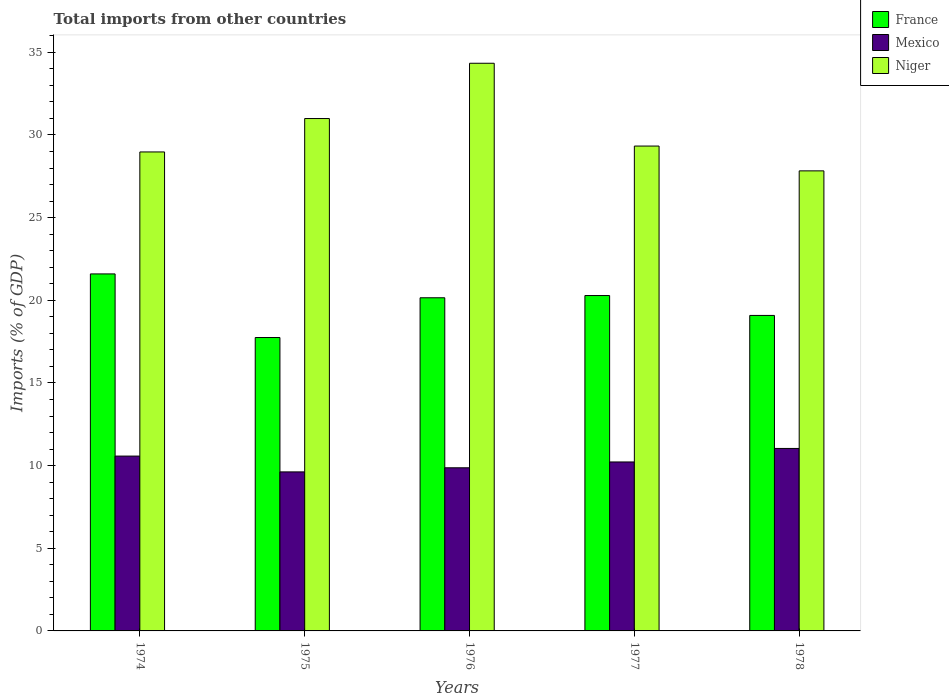How many different coloured bars are there?
Keep it short and to the point. 3. Are the number of bars per tick equal to the number of legend labels?
Your answer should be very brief. Yes. Are the number of bars on each tick of the X-axis equal?
Your answer should be very brief. Yes. How many bars are there on the 5th tick from the left?
Offer a terse response. 3. What is the label of the 5th group of bars from the left?
Your answer should be very brief. 1978. In how many cases, is the number of bars for a given year not equal to the number of legend labels?
Your answer should be compact. 0. What is the total imports in France in 1977?
Offer a very short reply. 20.29. Across all years, what is the maximum total imports in France?
Your response must be concise. 21.6. Across all years, what is the minimum total imports in Mexico?
Offer a terse response. 9.62. In which year was the total imports in Niger maximum?
Your answer should be very brief. 1976. In which year was the total imports in France minimum?
Make the answer very short. 1975. What is the total total imports in Mexico in the graph?
Give a very brief answer. 51.32. What is the difference between the total imports in Mexico in 1975 and that in 1978?
Your answer should be very brief. -1.42. What is the difference between the total imports in Mexico in 1977 and the total imports in France in 1978?
Offer a terse response. -8.86. What is the average total imports in Niger per year?
Ensure brevity in your answer.  30.29. In the year 1974, what is the difference between the total imports in France and total imports in Mexico?
Keep it short and to the point. 11.02. In how many years, is the total imports in Mexico greater than 18 %?
Offer a very short reply. 0. What is the ratio of the total imports in Mexico in 1977 to that in 1978?
Provide a short and direct response. 0.93. What is the difference between the highest and the second highest total imports in Mexico?
Offer a terse response. 0.46. What is the difference between the highest and the lowest total imports in Mexico?
Your answer should be very brief. 1.42. Is the sum of the total imports in France in 1977 and 1978 greater than the maximum total imports in Mexico across all years?
Make the answer very short. Yes. What does the 2nd bar from the left in 1978 represents?
Your response must be concise. Mexico. What does the 3rd bar from the right in 1974 represents?
Keep it short and to the point. France. Is it the case that in every year, the sum of the total imports in Niger and total imports in Mexico is greater than the total imports in France?
Keep it short and to the point. Yes. How many bars are there?
Offer a terse response. 15. What is the difference between two consecutive major ticks on the Y-axis?
Your answer should be very brief. 5. Are the values on the major ticks of Y-axis written in scientific E-notation?
Your response must be concise. No. Does the graph contain any zero values?
Your response must be concise. No. Where does the legend appear in the graph?
Provide a short and direct response. Top right. How many legend labels are there?
Ensure brevity in your answer.  3. What is the title of the graph?
Provide a succinct answer. Total imports from other countries. Does "Mauritius" appear as one of the legend labels in the graph?
Offer a terse response. No. What is the label or title of the X-axis?
Provide a succinct answer. Years. What is the label or title of the Y-axis?
Provide a succinct answer. Imports (% of GDP). What is the Imports (% of GDP) in France in 1974?
Make the answer very short. 21.6. What is the Imports (% of GDP) in Mexico in 1974?
Provide a succinct answer. 10.58. What is the Imports (% of GDP) of Niger in 1974?
Offer a terse response. 28.97. What is the Imports (% of GDP) in France in 1975?
Your answer should be very brief. 17.75. What is the Imports (% of GDP) in Mexico in 1975?
Provide a succinct answer. 9.62. What is the Imports (% of GDP) in Niger in 1975?
Your answer should be very brief. 30.99. What is the Imports (% of GDP) in France in 1976?
Offer a terse response. 20.15. What is the Imports (% of GDP) in Mexico in 1976?
Keep it short and to the point. 9.87. What is the Imports (% of GDP) of Niger in 1976?
Your answer should be very brief. 34.34. What is the Imports (% of GDP) in France in 1977?
Your answer should be compact. 20.29. What is the Imports (% of GDP) in Mexico in 1977?
Give a very brief answer. 10.22. What is the Imports (% of GDP) in Niger in 1977?
Your response must be concise. 29.33. What is the Imports (% of GDP) of France in 1978?
Make the answer very short. 19.08. What is the Imports (% of GDP) of Mexico in 1978?
Give a very brief answer. 11.04. What is the Imports (% of GDP) in Niger in 1978?
Offer a terse response. 27.83. Across all years, what is the maximum Imports (% of GDP) of France?
Your response must be concise. 21.6. Across all years, what is the maximum Imports (% of GDP) of Mexico?
Offer a very short reply. 11.04. Across all years, what is the maximum Imports (% of GDP) of Niger?
Your answer should be compact. 34.34. Across all years, what is the minimum Imports (% of GDP) in France?
Keep it short and to the point. 17.75. Across all years, what is the minimum Imports (% of GDP) in Mexico?
Your answer should be very brief. 9.62. Across all years, what is the minimum Imports (% of GDP) in Niger?
Your answer should be very brief. 27.83. What is the total Imports (% of GDP) of France in the graph?
Give a very brief answer. 98.87. What is the total Imports (% of GDP) of Mexico in the graph?
Ensure brevity in your answer.  51.32. What is the total Imports (% of GDP) of Niger in the graph?
Provide a short and direct response. 151.46. What is the difference between the Imports (% of GDP) of France in 1974 and that in 1975?
Provide a succinct answer. 3.85. What is the difference between the Imports (% of GDP) of Mexico in 1974 and that in 1975?
Offer a terse response. 0.96. What is the difference between the Imports (% of GDP) in Niger in 1974 and that in 1975?
Your answer should be very brief. -2.02. What is the difference between the Imports (% of GDP) of France in 1974 and that in 1976?
Your answer should be very brief. 1.44. What is the difference between the Imports (% of GDP) of Mexico in 1974 and that in 1976?
Your answer should be compact. 0.71. What is the difference between the Imports (% of GDP) of Niger in 1974 and that in 1976?
Your answer should be compact. -5.36. What is the difference between the Imports (% of GDP) of France in 1974 and that in 1977?
Give a very brief answer. 1.31. What is the difference between the Imports (% of GDP) of Mexico in 1974 and that in 1977?
Provide a succinct answer. 0.36. What is the difference between the Imports (% of GDP) of Niger in 1974 and that in 1977?
Your response must be concise. -0.36. What is the difference between the Imports (% of GDP) in France in 1974 and that in 1978?
Your answer should be compact. 2.51. What is the difference between the Imports (% of GDP) in Mexico in 1974 and that in 1978?
Give a very brief answer. -0.46. What is the difference between the Imports (% of GDP) in Niger in 1974 and that in 1978?
Make the answer very short. 1.14. What is the difference between the Imports (% of GDP) in France in 1975 and that in 1976?
Your answer should be very brief. -2.4. What is the difference between the Imports (% of GDP) in Mexico in 1975 and that in 1976?
Ensure brevity in your answer.  -0.25. What is the difference between the Imports (% of GDP) in Niger in 1975 and that in 1976?
Provide a succinct answer. -3.34. What is the difference between the Imports (% of GDP) of France in 1975 and that in 1977?
Your response must be concise. -2.54. What is the difference between the Imports (% of GDP) in Mexico in 1975 and that in 1977?
Offer a terse response. -0.6. What is the difference between the Imports (% of GDP) of Niger in 1975 and that in 1977?
Provide a short and direct response. 1.66. What is the difference between the Imports (% of GDP) of France in 1975 and that in 1978?
Offer a very short reply. -1.34. What is the difference between the Imports (% of GDP) in Mexico in 1975 and that in 1978?
Offer a very short reply. -1.42. What is the difference between the Imports (% of GDP) of Niger in 1975 and that in 1978?
Provide a succinct answer. 3.17. What is the difference between the Imports (% of GDP) of France in 1976 and that in 1977?
Provide a short and direct response. -0.13. What is the difference between the Imports (% of GDP) in Mexico in 1976 and that in 1977?
Make the answer very short. -0.35. What is the difference between the Imports (% of GDP) of Niger in 1976 and that in 1977?
Offer a terse response. 5.01. What is the difference between the Imports (% of GDP) of France in 1976 and that in 1978?
Provide a short and direct response. 1.07. What is the difference between the Imports (% of GDP) in Mexico in 1976 and that in 1978?
Make the answer very short. -1.17. What is the difference between the Imports (% of GDP) of Niger in 1976 and that in 1978?
Give a very brief answer. 6.51. What is the difference between the Imports (% of GDP) of France in 1977 and that in 1978?
Your answer should be compact. 1.2. What is the difference between the Imports (% of GDP) in Mexico in 1977 and that in 1978?
Keep it short and to the point. -0.82. What is the difference between the Imports (% of GDP) of Niger in 1977 and that in 1978?
Offer a very short reply. 1.5. What is the difference between the Imports (% of GDP) in France in 1974 and the Imports (% of GDP) in Mexico in 1975?
Make the answer very short. 11.98. What is the difference between the Imports (% of GDP) in France in 1974 and the Imports (% of GDP) in Niger in 1975?
Ensure brevity in your answer.  -9.4. What is the difference between the Imports (% of GDP) in Mexico in 1974 and the Imports (% of GDP) in Niger in 1975?
Make the answer very short. -20.42. What is the difference between the Imports (% of GDP) in France in 1974 and the Imports (% of GDP) in Mexico in 1976?
Offer a terse response. 11.73. What is the difference between the Imports (% of GDP) of France in 1974 and the Imports (% of GDP) of Niger in 1976?
Your answer should be very brief. -12.74. What is the difference between the Imports (% of GDP) in Mexico in 1974 and the Imports (% of GDP) in Niger in 1976?
Provide a succinct answer. -23.76. What is the difference between the Imports (% of GDP) of France in 1974 and the Imports (% of GDP) of Mexico in 1977?
Your answer should be very brief. 11.37. What is the difference between the Imports (% of GDP) in France in 1974 and the Imports (% of GDP) in Niger in 1977?
Offer a terse response. -7.73. What is the difference between the Imports (% of GDP) of Mexico in 1974 and the Imports (% of GDP) of Niger in 1977?
Offer a very short reply. -18.75. What is the difference between the Imports (% of GDP) of France in 1974 and the Imports (% of GDP) of Mexico in 1978?
Your response must be concise. 10.56. What is the difference between the Imports (% of GDP) in France in 1974 and the Imports (% of GDP) in Niger in 1978?
Offer a terse response. -6.23. What is the difference between the Imports (% of GDP) of Mexico in 1974 and the Imports (% of GDP) of Niger in 1978?
Offer a terse response. -17.25. What is the difference between the Imports (% of GDP) in France in 1975 and the Imports (% of GDP) in Mexico in 1976?
Offer a terse response. 7.88. What is the difference between the Imports (% of GDP) of France in 1975 and the Imports (% of GDP) of Niger in 1976?
Your response must be concise. -16.59. What is the difference between the Imports (% of GDP) in Mexico in 1975 and the Imports (% of GDP) in Niger in 1976?
Your answer should be compact. -24.72. What is the difference between the Imports (% of GDP) of France in 1975 and the Imports (% of GDP) of Mexico in 1977?
Ensure brevity in your answer.  7.53. What is the difference between the Imports (% of GDP) in France in 1975 and the Imports (% of GDP) in Niger in 1977?
Offer a very short reply. -11.58. What is the difference between the Imports (% of GDP) of Mexico in 1975 and the Imports (% of GDP) of Niger in 1977?
Offer a terse response. -19.71. What is the difference between the Imports (% of GDP) of France in 1975 and the Imports (% of GDP) of Mexico in 1978?
Give a very brief answer. 6.71. What is the difference between the Imports (% of GDP) in France in 1975 and the Imports (% of GDP) in Niger in 1978?
Keep it short and to the point. -10.08. What is the difference between the Imports (% of GDP) of Mexico in 1975 and the Imports (% of GDP) of Niger in 1978?
Your answer should be compact. -18.21. What is the difference between the Imports (% of GDP) in France in 1976 and the Imports (% of GDP) in Mexico in 1977?
Your answer should be compact. 9.93. What is the difference between the Imports (% of GDP) in France in 1976 and the Imports (% of GDP) in Niger in 1977?
Give a very brief answer. -9.18. What is the difference between the Imports (% of GDP) of Mexico in 1976 and the Imports (% of GDP) of Niger in 1977?
Offer a terse response. -19.46. What is the difference between the Imports (% of GDP) of France in 1976 and the Imports (% of GDP) of Mexico in 1978?
Offer a very short reply. 9.11. What is the difference between the Imports (% of GDP) in France in 1976 and the Imports (% of GDP) in Niger in 1978?
Provide a succinct answer. -7.68. What is the difference between the Imports (% of GDP) of Mexico in 1976 and the Imports (% of GDP) of Niger in 1978?
Your response must be concise. -17.96. What is the difference between the Imports (% of GDP) of France in 1977 and the Imports (% of GDP) of Mexico in 1978?
Give a very brief answer. 9.25. What is the difference between the Imports (% of GDP) in France in 1977 and the Imports (% of GDP) in Niger in 1978?
Make the answer very short. -7.54. What is the difference between the Imports (% of GDP) in Mexico in 1977 and the Imports (% of GDP) in Niger in 1978?
Provide a succinct answer. -17.61. What is the average Imports (% of GDP) of France per year?
Ensure brevity in your answer.  19.77. What is the average Imports (% of GDP) in Mexico per year?
Provide a short and direct response. 10.26. What is the average Imports (% of GDP) of Niger per year?
Offer a terse response. 30.29. In the year 1974, what is the difference between the Imports (% of GDP) in France and Imports (% of GDP) in Mexico?
Give a very brief answer. 11.02. In the year 1974, what is the difference between the Imports (% of GDP) in France and Imports (% of GDP) in Niger?
Your answer should be very brief. -7.38. In the year 1974, what is the difference between the Imports (% of GDP) of Mexico and Imports (% of GDP) of Niger?
Your answer should be very brief. -18.4. In the year 1975, what is the difference between the Imports (% of GDP) of France and Imports (% of GDP) of Mexico?
Make the answer very short. 8.13. In the year 1975, what is the difference between the Imports (% of GDP) of France and Imports (% of GDP) of Niger?
Give a very brief answer. -13.25. In the year 1975, what is the difference between the Imports (% of GDP) in Mexico and Imports (% of GDP) in Niger?
Give a very brief answer. -21.37. In the year 1976, what is the difference between the Imports (% of GDP) of France and Imports (% of GDP) of Mexico?
Provide a short and direct response. 10.29. In the year 1976, what is the difference between the Imports (% of GDP) in France and Imports (% of GDP) in Niger?
Provide a succinct answer. -14.19. In the year 1976, what is the difference between the Imports (% of GDP) in Mexico and Imports (% of GDP) in Niger?
Give a very brief answer. -24.47. In the year 1977, what is the difference between the Imports (% of GDP) in France and Imports (% of GDP) in Mexico?
Your answer should be very brief. 10.07. In the year 1977, what is the difference between the Imports (% of GDP) in France and Imports (% of GDP) in Niger?
Keep it short and to the point. -9.04. In the year 1977, what is the difference between the Imports (% of GDP) in Mexico and Imports (% of GDP) in Niger?
Ensure brevity in your answer.  -19.11. In the year 1978, what is the difference between the Imports (% of GDP) of France and Imports (% of GDP) of Mexico?
Provide a short and direct response. 8.05. In the year 1978, what is the difference between the Imports (% of GDP) in France and Imports (% of GDP) in Niger?
Your response must be concise. -8.74. In the year 1978, what is the difference between the Imports (% of GDP) in Mexico and Imports (% of GDP) in Niger?
Your answer should be very brief. -16.79. What is the ratio of the Imports (% of GDP) of France in 1974 to that in 1975?
Give a very brief answer. 1.22. What is the ratio of the Imports (% of GDP) of Mexico in 1974 to that in 1975?
Provide a short and direct response. 1.1. What is the ratio of the Imports (% of GDP) of Niger in 1974 to that in 1975?
Offer a very short reply. 0.93. What is the ratio of the Imports (% of GDP) of France in 1974 to that in 1976?
Provide a short and direct response. 1.07. What is the ratio of the Imports (% of GDP) in Mexico in 1974 to that in 1976?
Make the answer very short. 1.07. What is the ratio of the Imports (% of GDP) in Niger in 1974 to that in 1976?
Offer a terse response. 0.84. What is the ratio of the Imports (% of GDP) in France in 1974 to that in 1977?
Your response must be concise. 1.06. What is the ratio of the Imports (% of GDP) in Mexico in 1974 to that in 1977?
Offer a terse response. 1.03. What is the ratio of the Imports (% of GDP) in Niger in 1974 to that in 1977?
Your response must be concise. 0.99. What is the ratio of the Imports (% of GDP) in France in 1974 to that in 1978?
Offer a terse response. 1.13. What is the ratio of the Imports (% of GDP) of Mexico in 1974 to that in 1978?
Offer a very short reply. 0.96. What is the ratio of the Imports (% of GDP) of Niger in 1974 to that in 1978?
Your response must be concise. 1.04. What is the ratio of the Imports (% of GDP) in France in 1975 to that in 1976?
Your answer should be compact. 0.88. What is the ratio of the Imports (% of GDP) in Mexico in 1975 to that in 1976?
Give a very brief answer. 0.97. What is the ratio of the Imports (% of GDP) of Niger in 1975 to that in 1976?
Your response must be concise. 0.9. What is the ratio of the Imports (% of GDP) of France in 1975 to that in 1977?
Offer a terse response. 0.87. What is the ratio of the Imports (% of GDP) of Mexico in 1975 to that in 1977?
Your answer should be compact. 0.94. What is the ratio of the Imports (% of GDP) of Niger in 1975 to that in 1977?
Make the answer very short. 1.06. What is the ratio of the Imports (% of GDP) of Mexico in 1975 to that in 1978?
Give a very brief answer. 0.87. What is the ratio of the Imports (% of GDP) of Niger in 1975 to that in 1978?
Ensure brevity in your answer.  1.11. What is the ratio of the Imports (% of GDP) in France in 1976 to that in 1977?
Offer a very short reply. 0.99. What is the ratio of the Imports (% of GDP) in Mexico in 1976 to that in 1977?
Ensure brevity in your answer.  0.97. What is the ratio of the Imports (% of GDP) in Niger in 1976 to that in 1977?
Offer a terse response. 1.17. What is the ratio of the Imports (% of GDP) in France in 1976 to that in 1978?
Provide a succinct answer. 1.06. What is the ratio of the Imports (% of GDP) in Mexico in 1976 to that in 1978?
Your answer should be very brief. 0.89. What is the ratio of the Imports (% of GDP) of Niger in 1976 to that in 1978?
Your response must be concise. 1.23. What is the ratio of the Imports (% of GDP) of France in 1977 to that in 1978?
Make the answer very short. 1.06. What is the ratio of the Imports (% of GDP) of Mexico in 1977 to that in 1978?
Provide a short and direct response. 0.93. What is the ratio of the Imports (% of GDP) of Niger in 1977 to that in 1978?
Your answer should be compact. 1.05. What is the difference between the highest and the second highest Imports (% of GDP) in France?
Ensure brevity in your answer.  1.31. What is the difference between the highest and the second highest Imports (% of GDP) of Mexico?
Your answer should be compact. 0.46. What is the difference between the highest and the second highest Imports (% of GDP) in Niger?
Your answer should be very brief. 3.34. What is the difference between the highest and the lowest Imports (% of GDP) in France?
Make the answer very short. 3.85. What is the difference between the highest and the lowest Imports (% of GDP) of Mexico?
Give a very brief answer. 1.42. What is the difference between the highest and the lowest Imports (% of GDP) in Niger?
Ensure brevity in your answer.  6.51. 